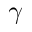<formula> <loc_0><loc_0><loc_500><loc_500>\gamma</formula> 